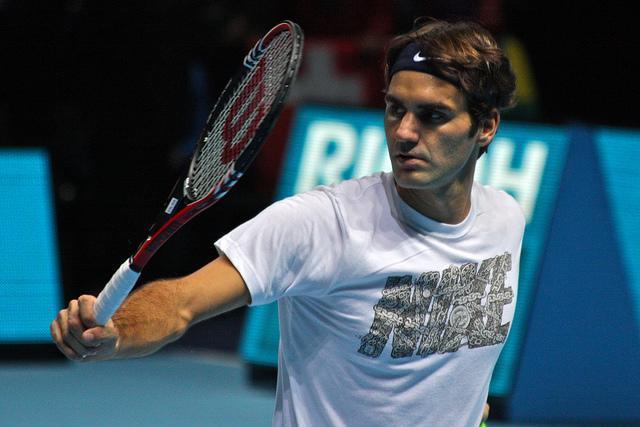How many street signs with a horse in it?
Give a very brief answer. 0. 